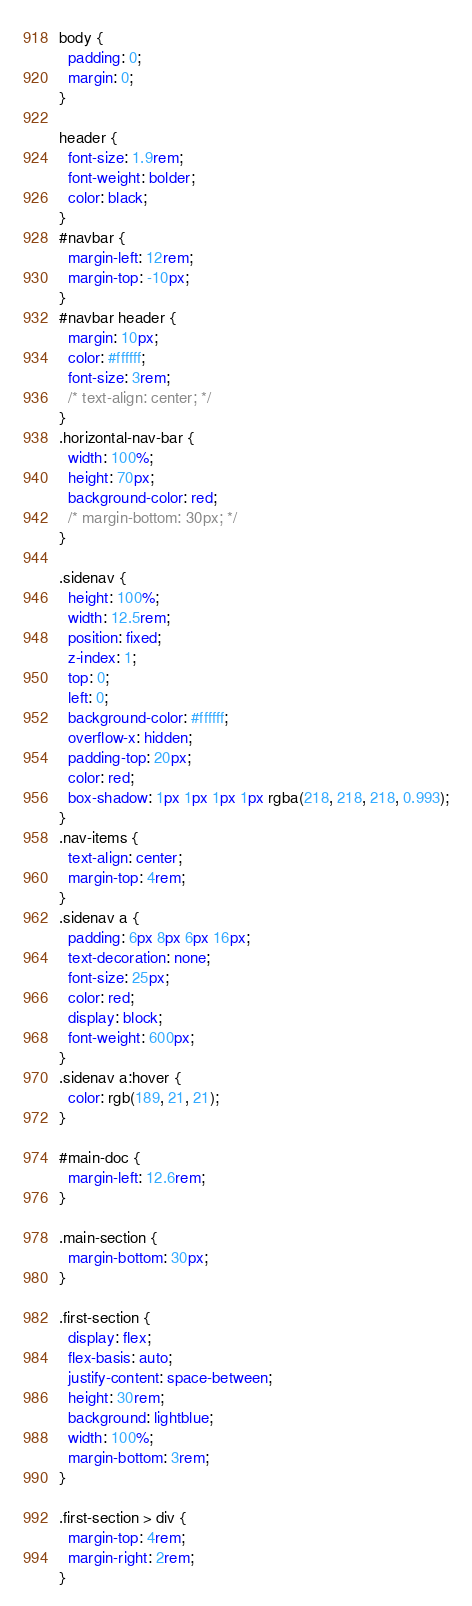<code> <loc_0><loc_0><loc_500><loc_500><_CSS_>body {
  padding: 0;
  margin: 0;
}

header {
  font-size: 1.9rem;
  font-weight: bolder;
  color: black;
}
#navbar {
  margin-left: 12rem;
  margin-top: -10px;
}
#navbar header {
  margin: 10px;
  color: #ffffff;
  font-size: 3rem;
  /* text-align: center; */
}
.horizontal-nav-bar {
  width: 100%;
  height: 70px;
  background-color: red;
  /* margin-bottom: 30px; */
}

.sidenav {
  height: 100%;
  width: 12.5rem;
  position: fixed;
  z-index: 1;
  top: 0;
  left: 0;
  background-color: #ffffff;
  overflow-x: hidden;
  padding-top: 20px;
  color: red;
  box-shadow: 1px 1px 1px 1px rgba(218, 218, 218, 0.993);
}
.nav-items {
  text-align: center;
  margin-top: 4rem;
}
.sidenav a {
  padding: 6px 8px 6px 16px;
  text-decoration: none;
  font-size: 25px;
  color: red;
  display: block;
  font-weight: 600px;
}
.sidenav a:hover {
  color: rgb(189, 21, 21);
}

#main-doc {
  margin-left: 12.6rem;
}

.main-section {
  margin-bottom: 30px;
}

.first-section {
  display: flex;
  flex-basis: auto;
  justify-content: space-between;
  height: 30rem;
  background: lightblue;
  width: 100%;
  margin-bottom: 3rem;
}

.first-section > div {
  margin-top: 4rem;
  margin-right: 2rem;
}</code> 